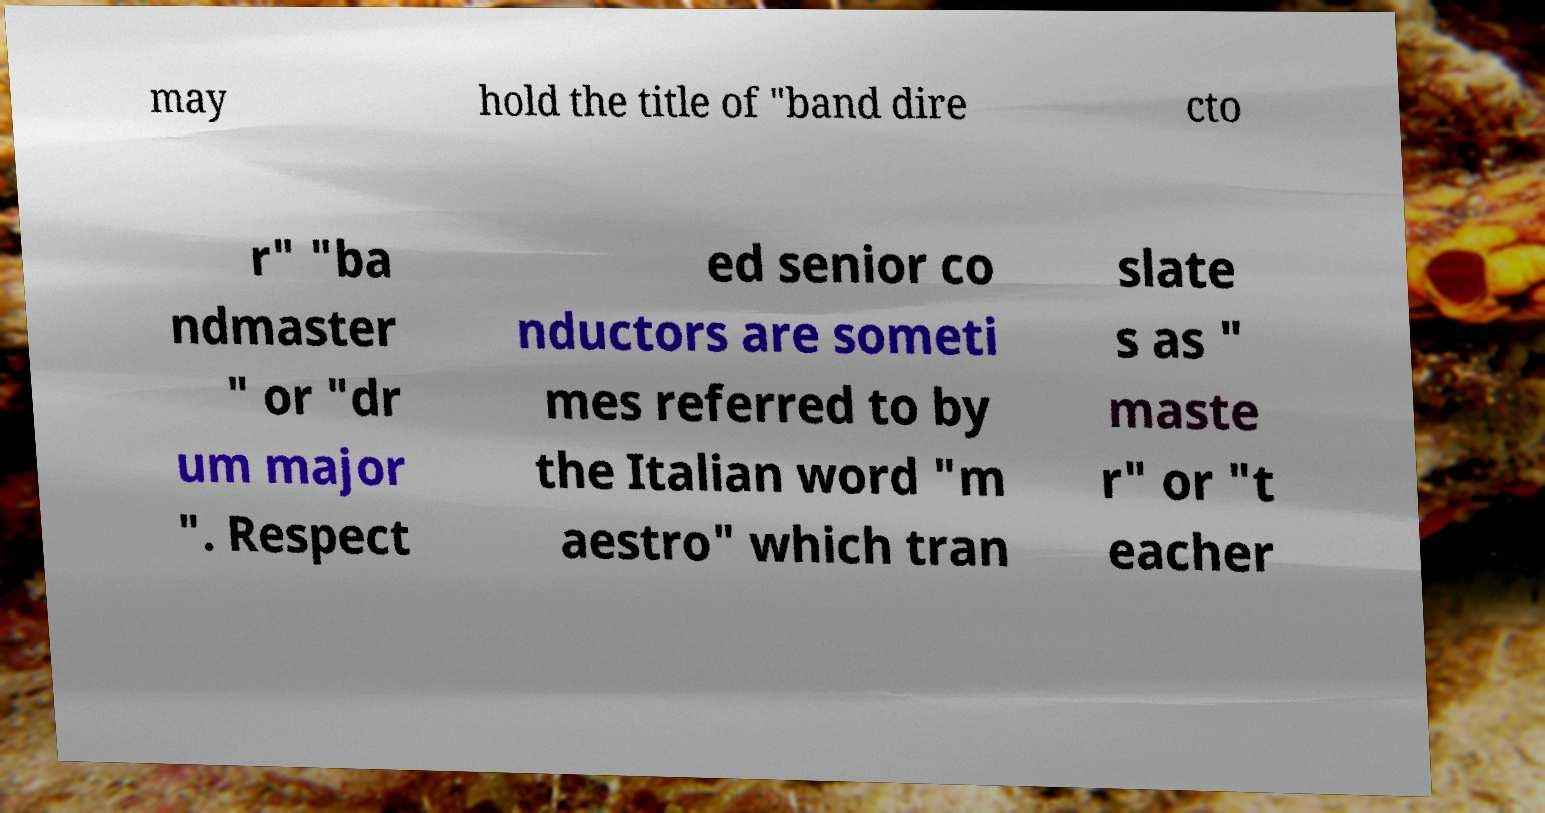For documentation purposes, I need the text within this image transcribed. Could you provide that? may hold the title of "band dire cto r" "ba ndmaster " or "dr um major ". Respect ed senior co nductors are someti mes referred to by the Italian word "m aestro" which tran slate s as " maste r" or "t eacher 